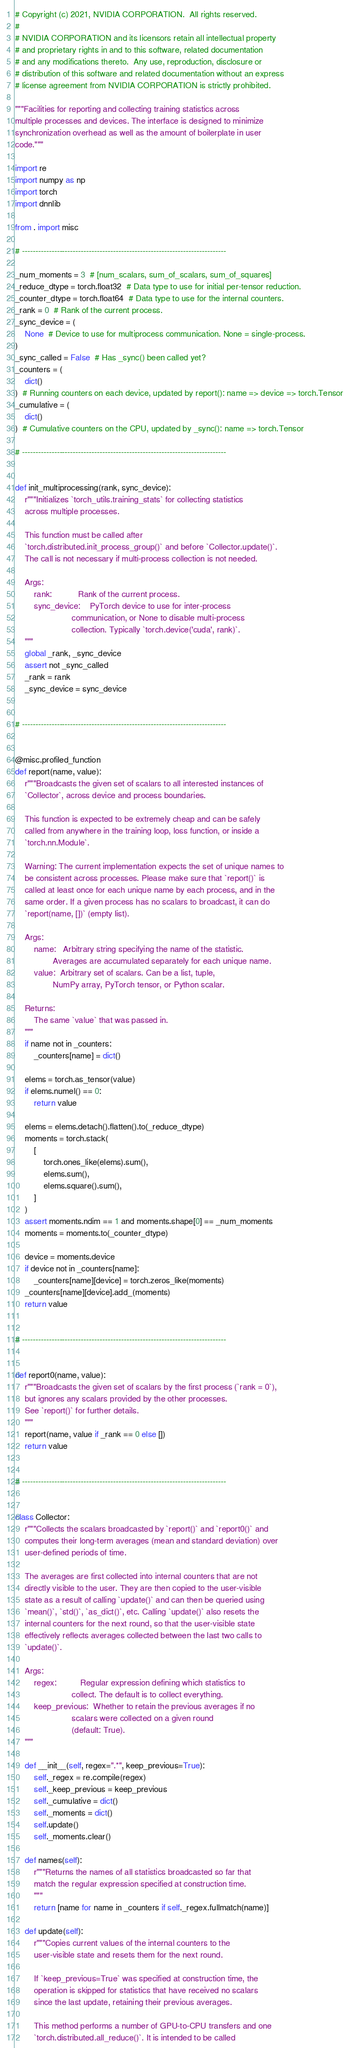Convert code to text. <code><loc_0><loc_0><loc_500><loc_500><_Python_># Copyright (c) 2021, NVIDIA CORPORATION.  All rights reserved.
#
# NVIDIA CORPORATION and its licensors retain all intellectual property
# and proprietary rights in and to this software, related documentation
# and any modifications thereto.  Any use, reproduction, disclosure or
# distribution of this software and related documentation without an express
# license agreement from NVIDIA CORPORATION is strictly prohibited.

"""Facilities for reporting and collecting training statistics across
multiple processes and devices. The interface is designed to minimize
synchronization overhead as well as the amount of boilerplate in user
code."""

import re
import numpy as np
import torch
import dnnlib

from . import misc

# ----------------------------------------------------------------------------

_num_moments = 3  # [num_scalars, sum_of_scalars, sum_of_squares]
_reduce_dtype = torch.float32  # Data type to use for initial per-tensor reduction.
_counter_dtype = torch.float64  # Data type to use for the internal counters.
_rank = 0  # Rank of the current process.
_sync_device = (
    None  # Device to use for multiprocess communication. None = single-process.
)
_sync_called = False  # Has _sync() been called yet?
_counters = (
    dict()
)  # Running counters on each device, updated by report(): name => device => torch.Tensor
_cumulative = (
    dict()
)  # Cumulative counters on the CPU, updated by _sync(): name => torch.Tensor

# ----------------------------------------------------------------------------


def init_multiprocessing(rank, sync_device):
    r"""Initializes `torch_utils.training_stats` for collecting statistics
    across multiple processes.

    This function must be called after
    `torch.distributed.init_process_group()` and before `Collector.update()`.
    The call is not necessary if multi-process collection is not needed.

    Args:
        rank:           Rank of the current process.
        sync_device:    PyTorch device to use for inter-process
                        communication, or None to disable multi-process
                        collection. Typically `torch.device('cuda', rank)`.
    """
    global _rank, _sync_device
    assert not _sync_called
    _rank = rank
    _sync_device = sync_device


# ----------------------------------------------------------------------------


@misc.profiled_function
def report(name, value):
    r"""Broadcasts the given set of scalars to all interested instances of
    `Collector`, across device and process boundaries.

    This function is expected to be extremely cheap and can be safely
    called from anywhere in the training loop, loss function, or inside a
    `torch.nn.Module`.

    Warning: The current implementation expects the set of unique names to
    be consistent across processes. Please make sure that `report()` is
    called at least once for each unique name by each process, and in the
    same order. If a given process has no scalars to broadcast, it can do
    `report(name, [])` (empty list).

    Args:
        name:   Arbitrary string specifying the name of the statistic.
                Averages are accumulated separately for each unique name.
        value:  Arbitrary set of scalars. Can be a list, tuple,
                NumPy array, PyTorch tensor, or Python scalar.

    Returns:
        The same `value` that was passed in.
    """
    if name not in _counters:
        _counters[name] = dict()

    elems = torch.as_tensor(value)
    if elems.numel() == 0:
        return value

    elems = elems.detach().flatten().to(_reduce_dtype)
    moments = torch.stack(
        [
            torch.ones_like(elems).sum(),
            elems.sum(),
            elems.square().sum(),
        ]
    )
    assert moments.ndim == 1 and moments.shape[0] == _num_moments
    moments = moments.to(_counter_dtype)

    device = moments.device
    if device not in _counters[name]:
        _counters[name][device] = torch.zeros_like(moments)
    _counters[name][device].add_(moments)
    return value


# ----------------------------------------------------------------------------


def report0(name, value):
    r"""Broadcasts the given set of scalars by the first process (`rank = 0`),
    but ignores any scalars provided by the other processes.
    See `report()` for further details.
    """
    report(name, value if _rank == 0 else [])
    return value


# ----------------------------------------------------------------------------


class Collector:
    r"""Collects the scalars broadcasted by `report()` and `report0()` and
    computes their long-term averages (mean and standard deviation) over
    user-defined periods of time.

    The averages are first collected into internal counters that are not
    directly visible to the user. They are then copied to the user-visible
    state as a result of calling `update()` and can then be queried using
    `mean()`, `std()`, `as_dict()`, etc. Calling `update()` also resets the
    internal counters for the next round, so that the user-visible state
    effectively reflects averages collected between the last two calls to
    `update()`.

    Args:
        regex:          Regular expression defining which statistics to
                        collect. The default is to collect everything.
        keep_previous:  Whether to retain the previous averages if no
                        scalars were collected on a given round
                        (default: True).
    """

    def __init__(self, regex=".*", keep_previous=True):
        self._regex = re.compile(regex)
        self._keep_previous = keep_previous
        self._cumulative = dict()
        self._moments = dict()
        self.update()
        self._moments.clear()

    def names(self):
        r"""Returns the names of all statistics broadcasted so far that
        match the regular expression specified at construction time.
        """
        return [name for name in _counters if self._regex.fullmatch(name)]

    def update(self):
        r"""Copies current values of the internal counters to the
        user-visible state and resets them for the next round.

        If `keep_previous=True` was specified at construction time, the
        operation is skipped for statistics that have received no scalars
        since the last update, retaining their previous averages.

        This method performs a number of GPU-to-CPU transfers and one
        `torch.distributed.all_reduce()`. It is intended to be called</code> 